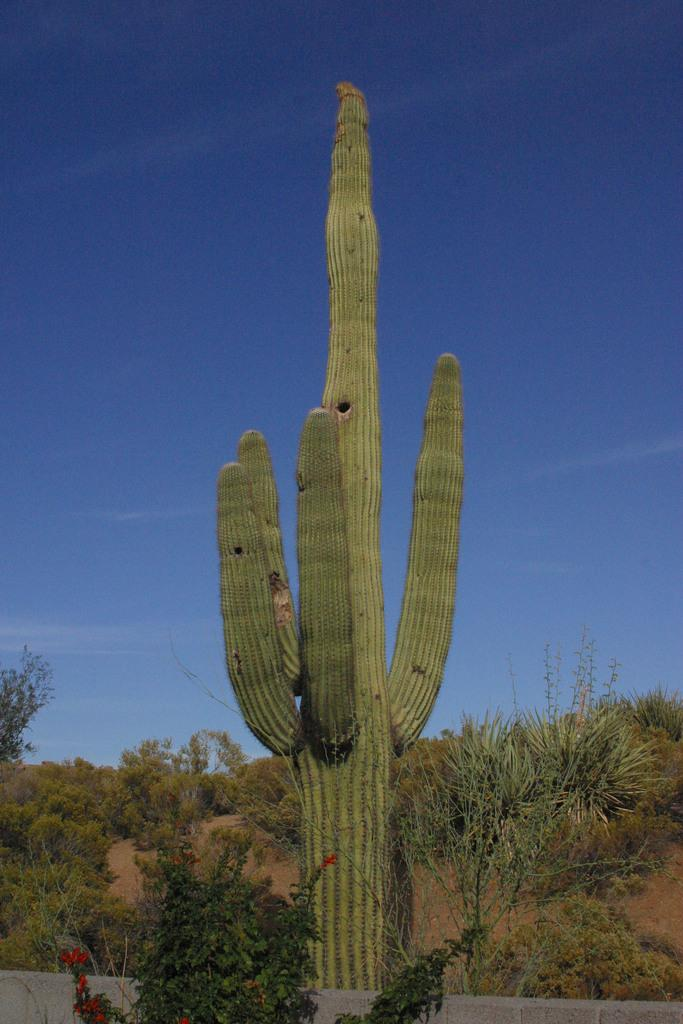What is the main subject in the center of the image? There is a cactus in the center of the image. What other types of plants can be seen in the image? There are plants in the image. What can be seen in the background of the image? There is a tree and the sky visible in the background of the image. Where is the dock located in the image? There is no dock present in the image. How many boys are visible in the image? There are no boys present in the image. 